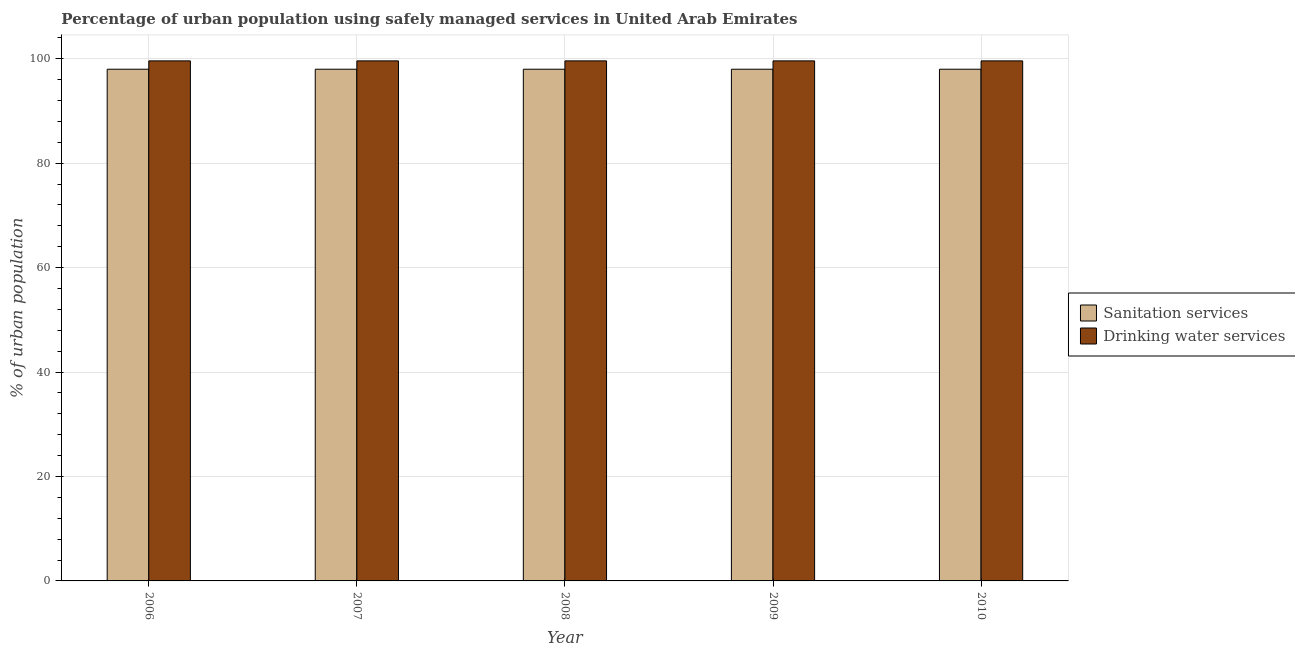How many bars are there on the 5th tick from the right?
Offer a very short reply. 2. What is the label of the 5th group of bars from the left?
Make the answer very short. 2010. In how many cases, is the number of bars for a given year not equal to the number of legend labels?
Your response must be concise. 0. What is the percentage of urban population who used sanitation services in 2010?
Your response must be concise. 98. Across all years, what is the maximum percentage of urban population who used drinking water services?
Your response must be concise. 99.6. Across all years, what is the minimum percentage of urban population who used sanitation services?
Provide a succinct answer. 98. In which year was the percentage of urban population who used drinking water services minimum?
Your response must be concise. 2006. What is the total percentage of urban population who used drinking water services in the graph?
Make the answer very short. 498. In how many years, is the percentage of urban population who used drinking water services greater than 92 %?
Keep it short and to the point. 5. Is the percentage of urban population who used drinking water services in 2006 less than that in 2010?
Offer a terse response. No. What does the 1st bar from the left in 2009 represents?
Make the answer very short. Sanitation services. What does the 1st bar from the right in 2008 represents?
Offer a very short reply. Drinking water services. Are all the bars in the graph horizontal?
Make the answer very short. No. How many years are there in the graph?
Give a very brief answer. 5. Are the values on the major ticks of Y-axis written in scientific E-notation?
Your answer should be compact. No. Does the graph contain grids?
Provide a short and direct response. Yes. Where does the legend appear in the graph?
Your response must be concise. Center right. What is the title of the graph?
Make the answer very short. Percentage of urban population using safely managed services in United Arab Emirates. Does "Male population" appear as one of the legend labels in the graph?
Keep it short and to the point. No. What is the label or title of the X-axis?
Your response must be concise. Year. What is the label or title of the Y-axis?
Make the answer very short. % of urban population. What is the % of urban population in Sanitation services in 2006?
Keep it short and to the point. 98. What is the % of urban population in Drinking water services in 2006?
Ensure brevity in your answer.  99.6. What is the % of urban population of Drinking water services in 2007?
Offer a terse response. 99.6. What is the % of urban population of Sanitation services in 2008?
Give a very brief answer. 98. What is the % of urban population in Drinking water services in 2008?
Provide a succinct answer. 99.6. What is the % of urban population in Sanitation services in 2009?
Provide a short and direct response. 98. What is the % of urban population in Drinking water services in 2009?
Ensure brevity in your answer.  99.6. What is the % of urban population in Drinking water services in 2010?
Your answer should be very brief. 99.6. Across all years, what is the maximum % of urban population in Sanitation services?
Ensure brevity in your answer.  98. Across all years, what is the maximum % of urban population of Drinking water services?
Give a very brief answer. 99.6. Across all years, what is the minimum % of urban population of Drinking water services?
Provide a short and direct response. 99.6. What is the total % of urban population in Sanitation services in the graph?
Your response must be concise. 490. What is the total % of urban population of Drinking water services in the graph?
Keep it short and to the point. 498. What is the difference between the % of urban population in Drinking water services in 2006 and that in 2008?
Offer a terse response. 0. What is the difference between the % of urban population in Sanitation services in 2006 and that in 2009?
Your response must be concise. 0. What is the difference between the % of urban population of Sanitation services in 2006 and that in 2010?
Your response must be concise. 0. What is the difference between the % of urban population in Sanitation services in 2007 and that in 2008?
Keep it short and to the point. 0. What is the difference between the % of urban population of Sanitation services in 2007 and that in 2009?
Give a very brief answer. 0. What is the difference between the % of urban population of Drinking water services in 2007 and that in 2010?
Your answer should be compact. 0. What is the difference between the % of urban population in Drinking water services in 2008 and that in 2009?
Offer a terse response. 0. What is the difference between the % of urban population in Sanitation services in 2008 and that in 2010?
Provide a succinct answer. 0. What is the difference between the % of urban population in Sanitation services in 2009 and that in 2010?
Your response must be concise. 0. What is the difference between the % of urban population of Drinking water services in 2009 and that in 2010?
Your response must be concise. 0. What is the difference between the % of urban population of Sanitation services in 2006 and the % of urban population of Drinking water services in 2008?
Give a very brief answer. -1.6. What is the difference between the % of urban population in Sanitation services in 2007 and the % of urban population in Drinking water services in 2008?
Your answer should be compact. -1.6. What is the difference between the % of urban population of Sanitation services in 2007 and the % of urban population of Drinking water services in 2010?
Your response must be concise. -1.6. What is the difference between the % of urban population of Sanitation services in 2009 and the % of urban population of Drinking water services in 2010?
Offer a very short reply. -1.6. What is the average % of urban population of Sanitation services per year?
Provide a short and direct response. 98. What is the average % of urban population of Drinking water services per year?
Ensure brevity in your answer.  99.6. In the year 2007, what is the difference between the % of urban population of Sanitation services and % of urban population of Drinking water services?
Your response must be concise. -1.6. In the year 2008, what is the difference between the % of urban population in Sanitation services and % of urban population in Drinking water services?
Make the answer very short. -1.6. In the year 2009, what is the difference between the % of urban population of Sanitation services and % of urban population of Drinking water services?
Offer a terse response. -1.6. In the year 2010, what is the difference between the % of urban population of Sanitation services and % of urban population of Drinking water services?
Ensure brevity in your answer.  -1.6. What is the ratio of the % of urban population of Sanitation services in 2006 to that in 2007?
Your response must be concise. 1. What is the ratio of the % of urban population in Sanitation services in 2006 to that in 2008?
Offer a terse response. 1. What is the ratio of the % of urban population in Sanitation services in 2006 to that in 2009?
Offer a very short reply. 1. What is the ratio of the % of urban population of Sanitation services in 2006 to that in 2010?
Offer a terse response. 1. What is the ratio of the % of urban population in Drinking water services in 2006 to that in 2010?
Offer a very short reply. 1. What is the ratio of the % of urban population in Sanitation services in 2007 to that in 2009?
Ensure brevity in your answer.  1. What is the ratio of the % of urban population in Drinking water services in 2008 to that in 2009?
Ensure brevity in your answer.  1. What is the ratio of the % of urban population in Sanitation services in 2008 to that in 2010?
Offer a terse response. 1. What is the ratio of the % of urban population of Drinking water services in 2008 to that in 2010?
Give a very brief answer. 1. What is the ratio of the % of urban population in Sanitation services in 2009 to that in 2010?
Make the answer very short. 1. What is the difference between the highest and the lowest % of urban population of Drinking water services?
Keep it short and to the point. 0. 